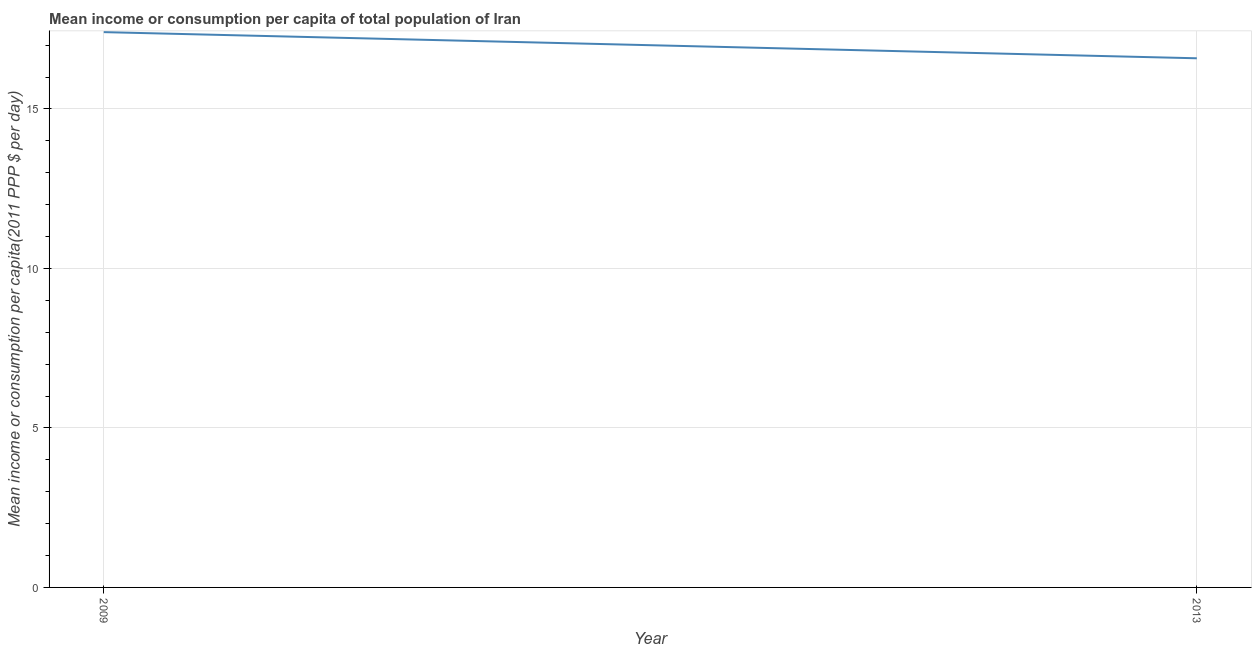What is the mean income or consumption in 2009?
Keep it short and to the point. 17.41. Across all years, what is the maximum mean income or consumption?
Make the answer very short. 17.41. Across all years, what is the minimum mean income or consumption?
Provide a succinct answer. 16.59. In which year was the mean income or consumption maximum?
Give a very brief answer. 2009. What is the difference between the mean income or consumption in 2009 and 2013?
Offer a terse response. 0.82. What is the median mean income or consumption?
Your answer should be very brief. 17. In how many years, is the mean income or consumption greater than 1 $?
Provide a succinct answer. 2. Do a majority of the years between 2013 and 2009 (inclusive) have mean income or consumption greater than 8 $?
Provide a short and direct response. No. What is the ratio of the mean income or consumption in 2009 to that in 2013?
Your answer should be very brief. 1.05. In how many years, is the mean income or consumption greater than the average mean income or consumption taken over all years?
Provide a succinct answer. 1. How many lines are there?
Ensure brevity in your answer.  1. How many years are there in the graph?
Offer a very short reply. 2. Are the values on the major ticks of Y-axis written in scientific E-notation?
Ensure brevity in your answer.  No. Does the graph contain any zero values?
Ensure brevity in your answer.  No. What is the title of the graph?
Your response must be concise. Mean income or consumption per capita of total population of Iran. What is the label or title of the Y-axis?
Your response must be concise. Mean income or consumption per capita(2011 PPP $ per day). What is the Mean income or consumption per capita(2011 PPP $ per day) in 2009?
Offer a very short reply. 17.41. What is the Mean income or consumption per capita(2011 PPP $ per day) of 2013?
Provide a succinct answer. 16.59. What is the difference between the Mean income or consumption per capita(2011 PPP $ per day) in 2009 and 2013?
Keep it short and to the point. 0.82. What is the ratio of the Mean income or consumption per capita(2011 PPP $ per day) in 2009 to that in 2013?
Your answer should be very brief. 1.05. 